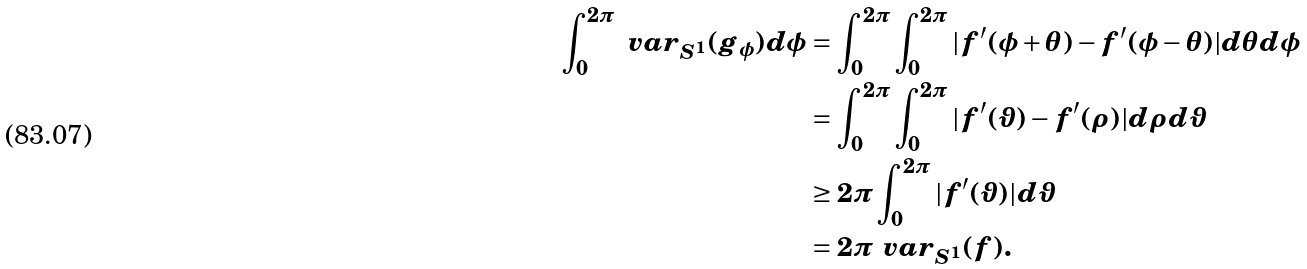Convert formula to latex. <formula><loc_0><loc_0><loc_500><loc_500>\int _ { 0 } ^ { 2 \pi } \ v a r _ { S ^ { 1 } } ( g _ { \phi } ) d \phi & = \int _ { 0 } ^ { 2 \pi } \int _ { 0 } ^ { 2 \pi } | f ^ { \prime } ( \phi + \theta ) - f ^ { \prime } ( \phi - \theta ) | d \theta d \phi \\ & = \int _ { 0 } ^ { 2 \pi } \int _ { 0 } ^ { 2 \pi } | f ^ { \prime } ( \vartheta ) - f ^ { \prime } ( \rho ) | d \rho d \vartheta \\ & \geq 2 \pi \int _ { 0 } ^ { 2 \pi } | f ^ { \prime } ( \vartheta ) | d \vartheta \\ & = 2 \pi \ v a r _ { S ^ { 1 } } ( f ) .</formula> 